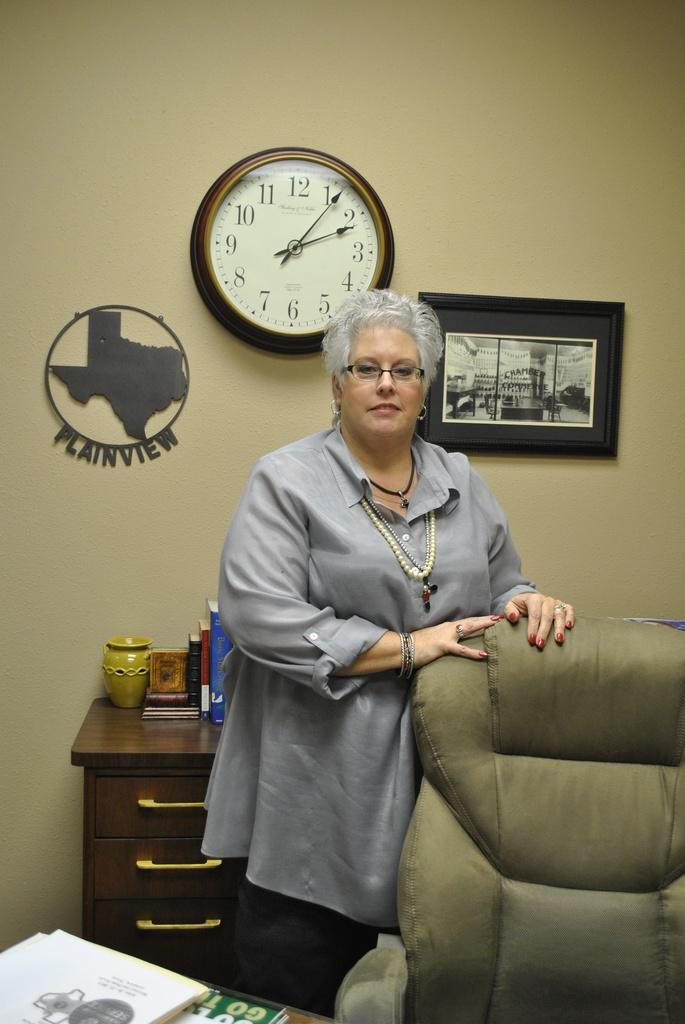<image>
Give a short and clear explanation of the subsequent image. A woman stands by a chair with a metal replica of the state of Texas with Plainview below it. 